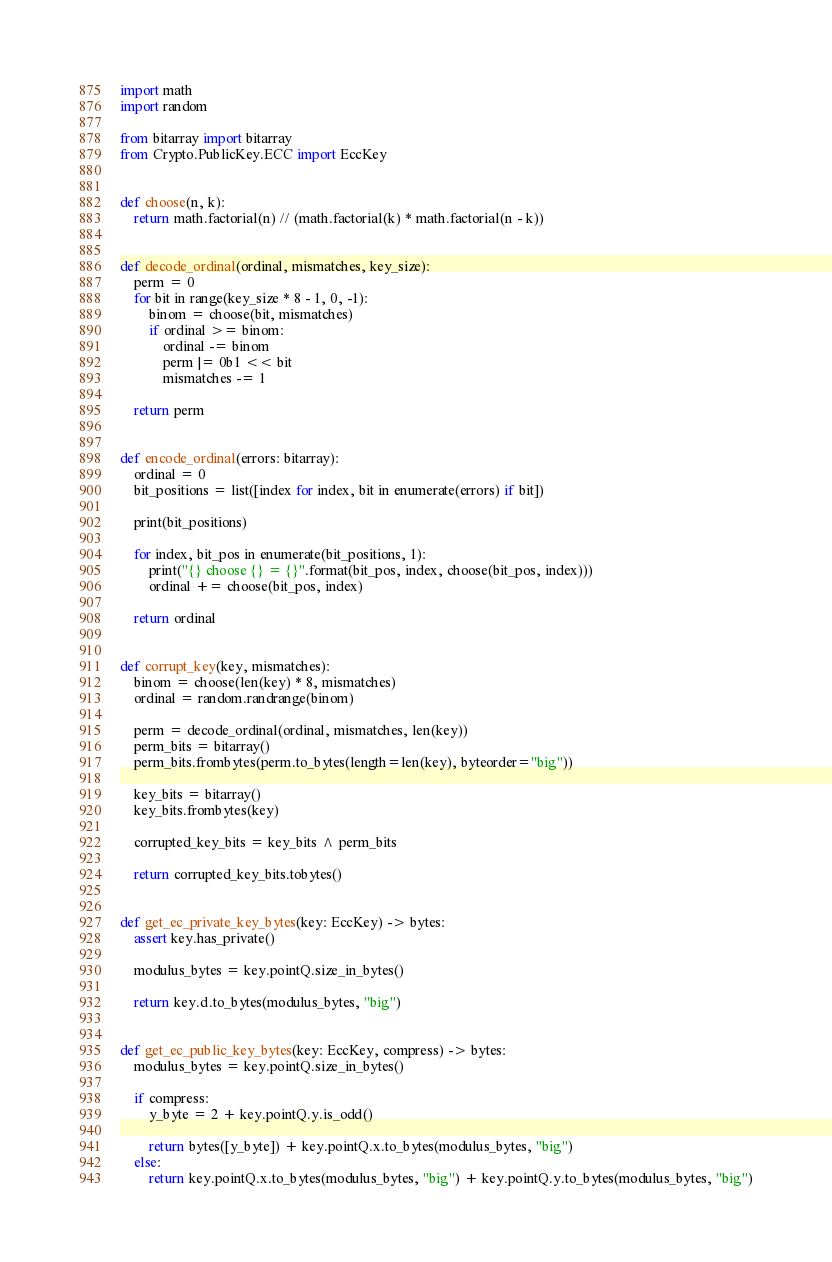<code> <loc_0><loc_0><loc_500><loc_500><_Python_>import math
import random

from bitarray import bitarray
from Crypto.PublicKey.ECC import EccKey


def choose(n, k):
    return math.factorial(n) // (math.factorial(k) * math.factorial(n - k))


def decode_ordinal(ordinal, mismatches, key_size):
    perm = 0
    for bit in range(key_size * 8 - 1, 0, -1):
        binom = choose(bit, mismatches)
        if ordinal >= binom:
            ordinal -= binom
            perm |= 0b1 << bit
            mismatches -= 1

    return perm


def encode_ordinal(errors: bitarray):
    ordinal = 0
    bit_positions = list([index for index, bit in enumerate(errors) if bit])

    print(bit_positions)

    for index, bit_pos in enumerate(bit_positions, 1):
        print("{} choose {} = {}".format(bit_pos, index, choose(bit_pos, index)))
        ordinal += choose(bit_pos, index)

    return ordinal


def corrupt_key(key, mismatches):
    binom = choose(len(key) * 8, mismatches)
    ordinal = random.randrange(binom)

    perm = decode_ordinal(ordinal, mismatches, len(key))
    perm_bits = bitarray()
    perm_bits.frombytes(perm.to_bytes(length=len(key), byteorder="big"))

    key_bits = bitarray()
    key_bits.frombytes(key)

    corrupted_key_bits = key_bits ^ perm_bits

    return corrupted_key_bits.tobytes()


def get_ec_private_key_bytes(key: EccKey) -> bytes:
    assert key.has_private()

    modulus_bytes = key.pointQ.size_in_bytes()

    return key.d.to_bytes(modulus_bytes, "big")


def get_ec_public_key_bytes(key: EccKey, compress) -> bytes:
    modulus_bytes = key.pointQ.size_in_bytes()

    if compress:
        y_byte = 2 + key.pointQ.y.is_odd()

        return bytes([y_byte]) + key.pointQ.x.to_bytes(modulus_bytes, "big")
    else:
        return key.pointQ.x.to_bytes(modulus_bytes, "big") + key.pointQ.y.to_bytes(modulus_bytes, "big")</code> 